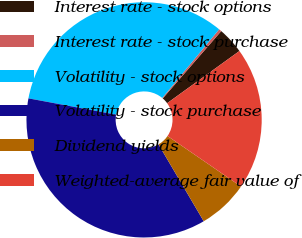<chart> <loc_0><loc_0><loc_500><loc_500><pie_chart><fcel>Interest rate - stock options<fcel>Interest rate - stock purchase<fcel>Volatility - stock options<fcel>Volatility - stock purchase<fcel>Dividend yields<fcel>Weighted-average fair value of<nl><fcel>3.66%<fcel>0.37%<fcel>33.09%<fcel>36.39%<fcel>6.95%<fcel>19.54%<nl></chart> 